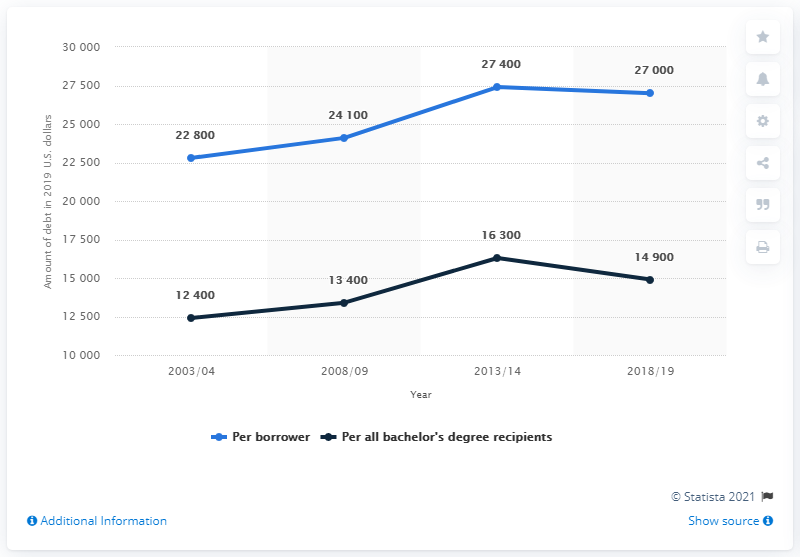List a handful of essential elements in this visual. The total amount for each borrower is 101,300. The year with the highest debt was 2013/14. 